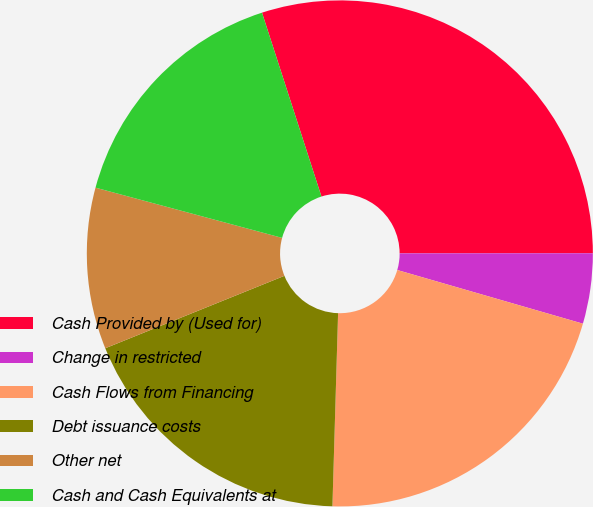Convert chart. <chart><loc_0><loc_0><loc_500><loc_500><pie_chart><fcel>Cash Provided by (Used for)<fcel>Change in restricted<fcel>Cash Flows from Financing<fcel>Debt issuance costs<fcel>Other net<fcel>Cash and Cash Equivalents at<nl><fcel>29.97%<fcel>4.49%<fcel>20.99%<fcel>18.42%<fcel>10.3%<fcel>15.84%<nl></chart> 